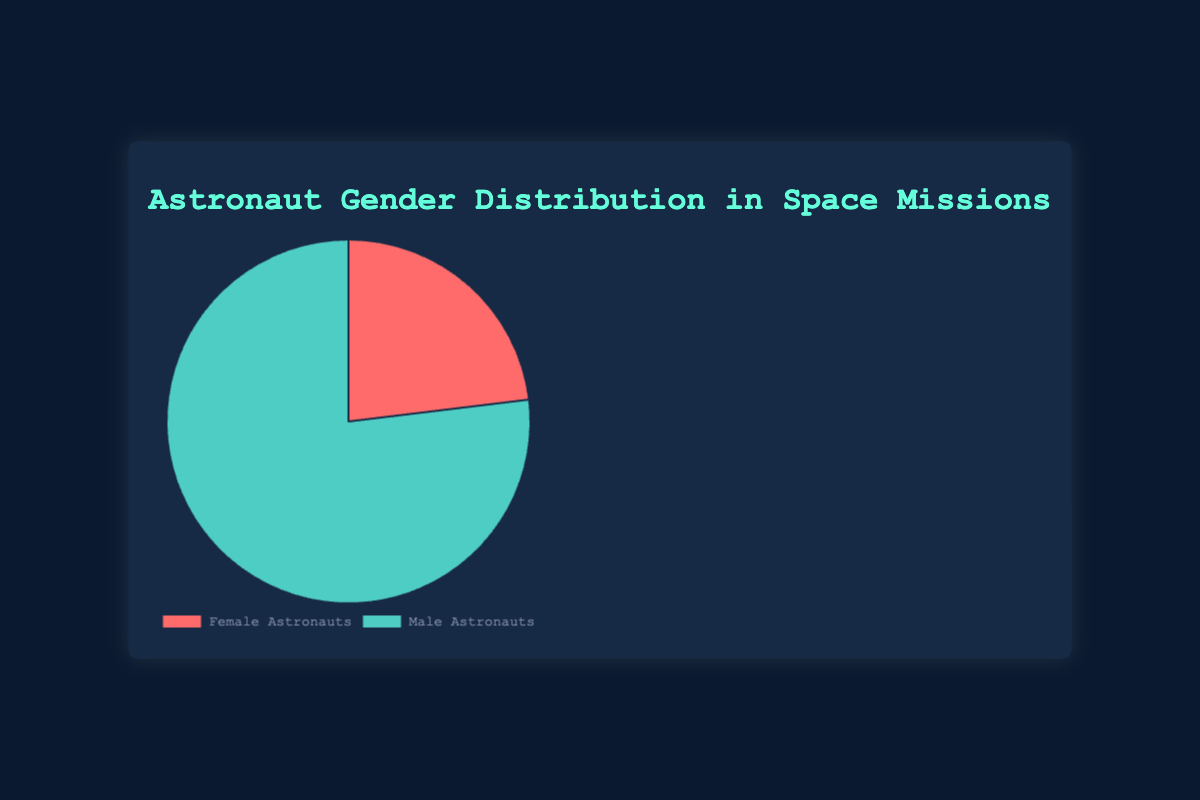What percentage of astronauts were female? The pie chart shows the distribution of female and male astronauts. With 6 female and 20 male astronauts, there are 6 females out of a total of 26 astronauts, which calculates to (6/26)*100.
Answer: 23.1% What is the ratio of male to female astronauts? Based on the pie chart, there are 20 male astronauts and 6 female astronauts. The ratio is 20:6, which simplifies to 10:3.
Answer: 10:3 How many more male astronauts were there compared to female astronauts? The pie chart indicates there are 20 male astronauts and 6 female astronauts. The difference is calculated as 20 - 6.
Answer: 14 What's the median number of astronauts per gender group? There are a total of 6 female and 20 male astronauts. The numbers are already sorted (6, 20). For two numbers, the median is the average of these two: (6 + 20) / 2.
Answer: 13 What proportion of the total astronauts were female? The pie chart shows 6 female astronauts out of a total of 26 astronauts. The proportion is 6/26.
Answer: 6/26 Are there more male astronauts or female astronauts? The pie chart shows the section for male astronauts is larger than the section for female astronauts.
Answer: Male astronauts Which slice of the pie chart is larger, female or male astronauts? Observing the pie chart, the section representing male astronauts is visibly larger.
Answer: Male astronauts How many astronauts in total were involved in the space missions? The summary of data from the pie chart adds up 6 female and 20 male astronauts, which totals to 6 + 20.
Answer: 26 